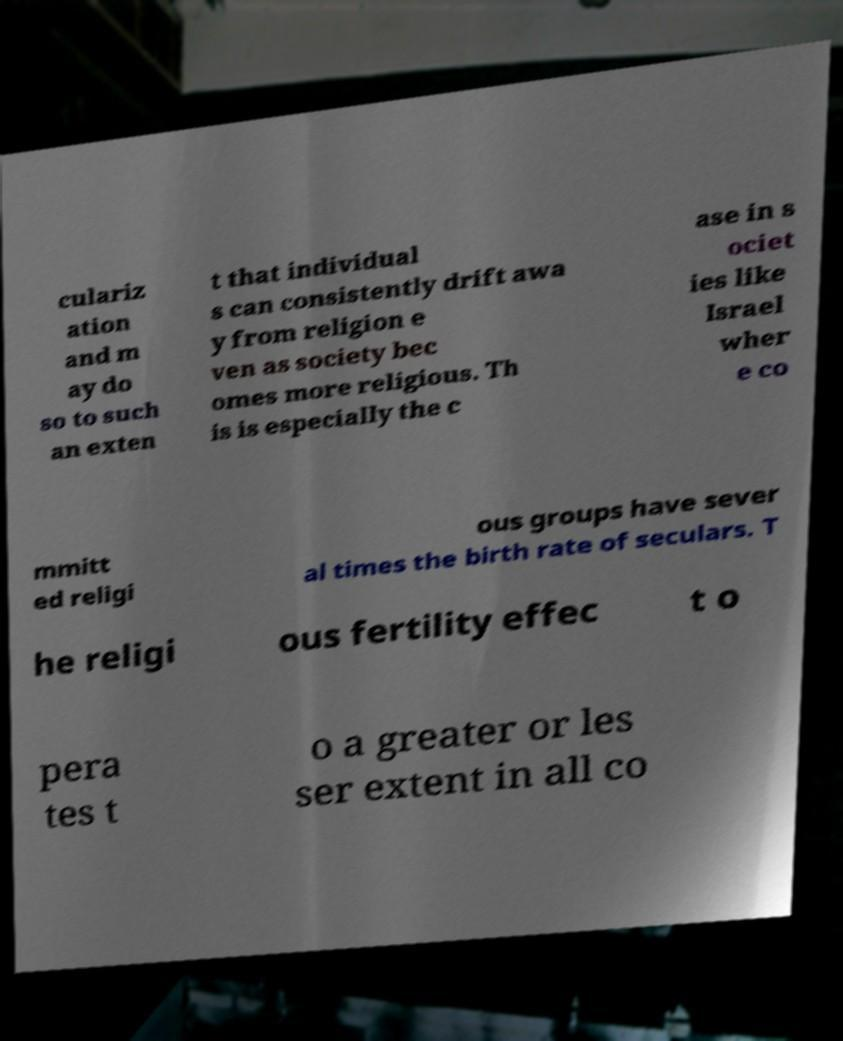Please read and relay the text visible in this image. What does it say? culariz ation and m ay do so to such an exten t that individual s can consistently drift awa y from religion e ven as society bec omes more religious. Th is is especially the c ase in s ociet ies like Israel wher e co mmitt ed religi ous groups have sever al times the birth rate of seculars. T he religi ous fertility effec t o pera tes t o a greater or les ser extent in all co 